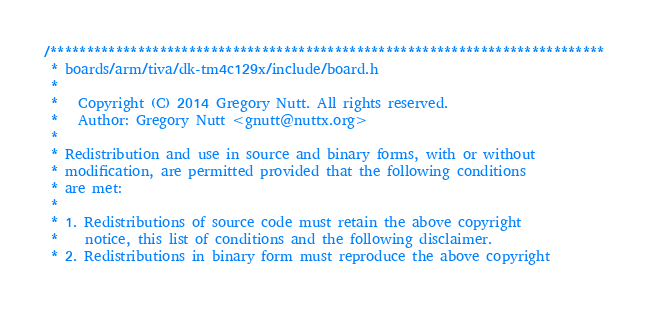<code> <loc_0><loc_0><loc_500><loc_500><_C_>/****************************************************************************
 * boards/arm/tiva/dk-tm4c129x/include/board.h
 *
 *   Copyright (C) 2014 Gregory Nutt. All rights reserved.
 *   Author: Gregory Nutt <gnutt@nuttx.org>
 *
 * Redistribution and use in source and binary forms, with or without
 * modification, are permitted provided that the following conditions
 * are met:
 *
 * 1. Redistributions of source code must retain the above copyright
 *    notice, this list of conditions and the following disclaimer.
 * 2. Redistributions in binary form must reproduce the above copyright</code> 